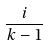Convert formula to latex. <formula><loc_0><loc_0><loc_500><loc_500>\frac { i } { k - 1 }</formula> 